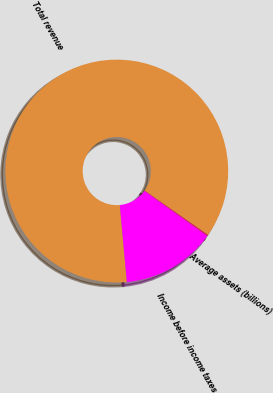<chart> <loc_0><loc_0><loc_500><loc_500><pie_chart><fcel>Total revenue<fcel>Income before income taxes<fcel>Average assets (billions)<nl><fcel>86.18%<fcel>13.66%<fcel>0.16%<nl></chart> 